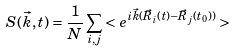Convert formula to latex. <formula><loc_0><loc_0><loc_500><loc_500>S ( \vec { k } , t ) = \frac { 1 } { N } \sum _ { i , j } < e ^ { i \vec { k } ( \vec { R } _ { i } ( t ) - \vec { R } _ { j } ( t _ { 0 } ) ) } ></formula> 